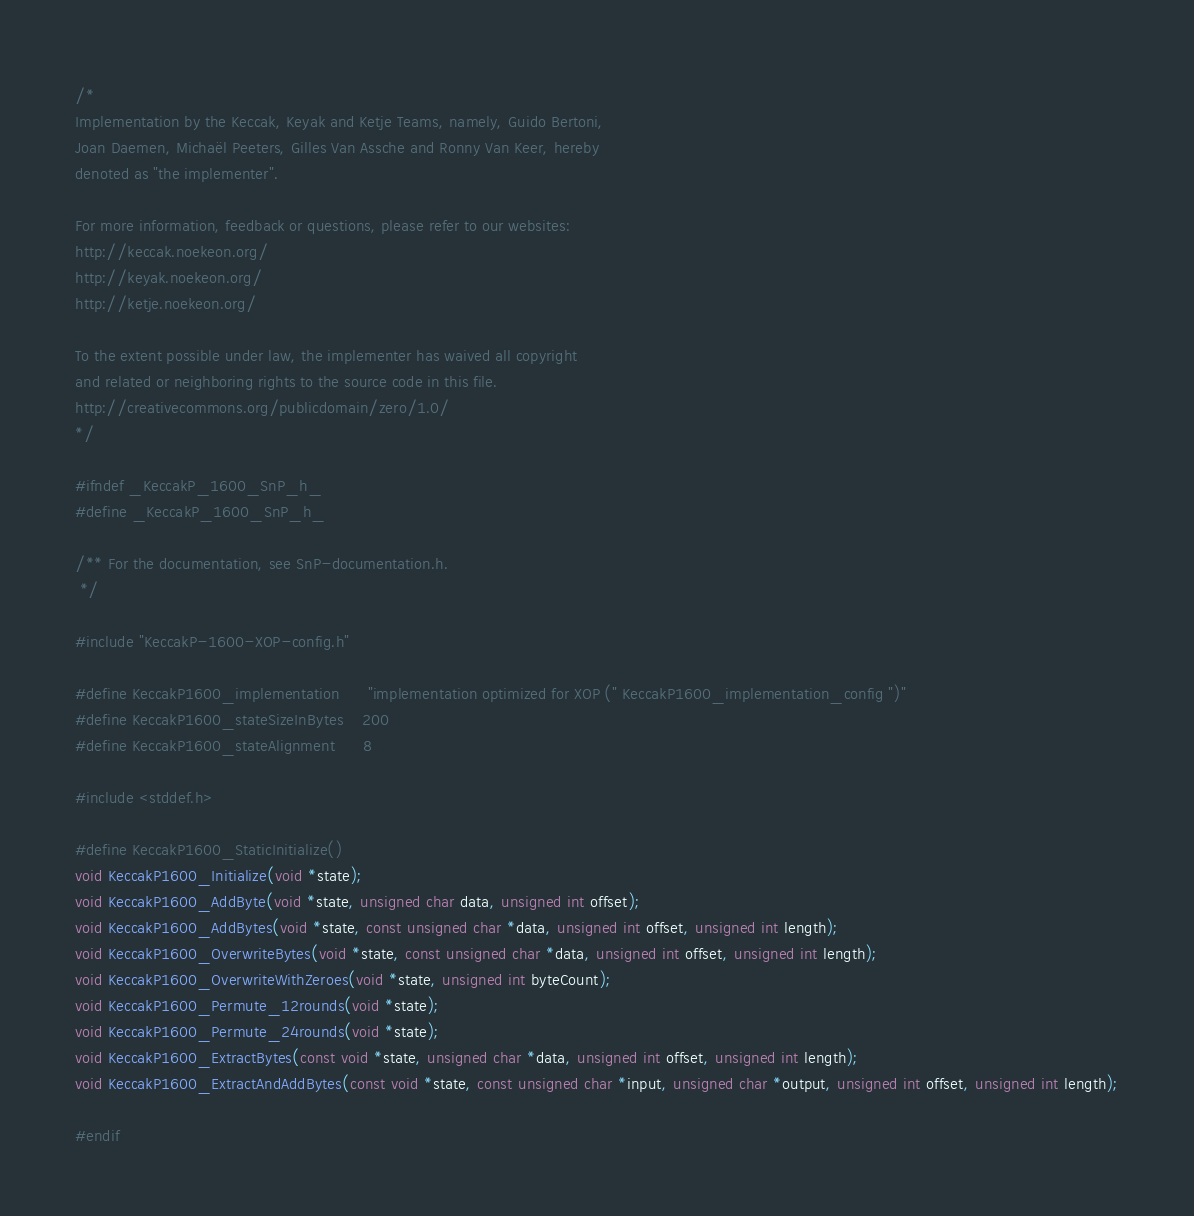Convert code to text. <code><loc_0><loc_0><loc_500><loc_500><_C_>/*
Implementation by the Keccak, Keyak and Ketje Teams, namely, Guido Bertoni,
Joan Daemen, Michaël Peeters, Gilles Van Assche and Ronny Van Keer, hereby
denoted as "the implementer".

For more information, feedback or questions, please refer to our websites:
http://keccak.noekeon.org/
http://keyak.noekeon.org/
http://ketje.noekeon.org/

To the extent possible under law, the implementer has waived all copyright
and related or neighboring rights to the source code in this file.
http://creativecommons.org/publicdomain/zero/1.0/
*/

#ifndef _KeccakP_1600_SnP_h_
#define _KeccakP_1600_SnP_h_

/** For the documentation, see SnP-documentation.h.
 */

#include "KeccakP-1600-XOP-config.h"

#define KeccakP1600_implementation      "implementation optimized for XOP (" KeccakP1600_implementation_config ")"
#define KeccakP1600_stateSizeInBytes    200
#define KeccakP1600_stateAlignment      8

#include <stddef.h>

#define KeccakP1600_StaticInitialize()
void KeccakP1600_Initialize(void *state);
void KeccakP1600_AddByte(void *state, unsigned char data, unsigned int offset);
void KeccakP1600_AddBytes(void *state, const unsigned char *data, unsigned int offset, unsigned int length);
void KeccakP1600_OverwriteBytes(void *state, const unsigned char *data, unsigned int offset, unsigned int length);
void KeccakP1600_OverwriteWithZeroes(void *state, unsigned int byteCount);
void KeccakP1600_Permute_12rounds(void *state);
void KeccakP1600_Permute_24rounds(void *state);
void KeccakP1600_ExtractBytes(const void *state, unsigned char *data, unsigned int offset, unsigned int length);
void KeccakP1600_ExtractAndAddBytes(const void *state, const unsigned char *input, unsigned char *output, unsigned int offset, unsigned int length);

#endif
</code> 